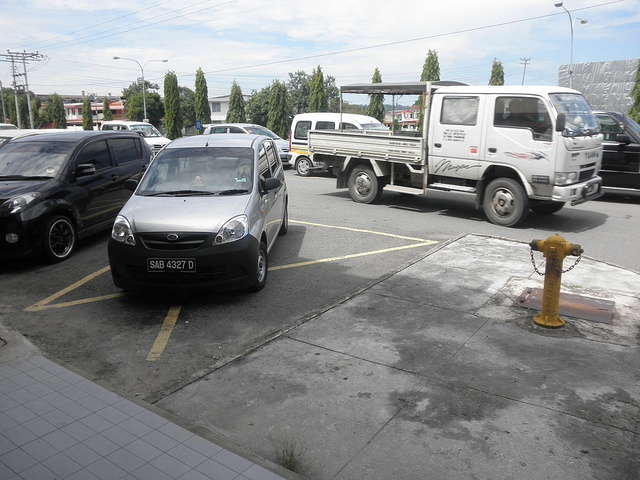Describe the objects in this image and their specific colors. I can see truck in lightblue, lightgray, darkgray, gray, and black tones, car in lightblue, black, lightgray, darkgray, and gray tones, car in lightblue, black, gray, and darkgray tones, truck in lightblue, black, gray, and darkgray tones, and truck in lightblue, black, gray, darkgray, and purple tones in this image. 